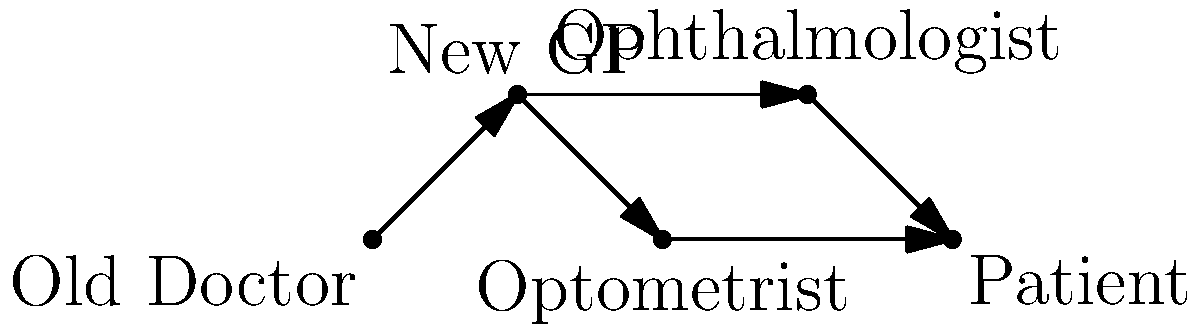In the given network graph representing the referral process for an annual sight check, what is the minimum number of steps (edges) required for the patient to reach the ophthalmologist from their old doctor? To determine the minimum number of steps required for the patient to reach the ophthalmologist from their old doctor, we need to analyze the graph:

1. Start at the "Old Doctor" node.
2. The only path from the "Old Doctor" is to the "New GP" (1 step).
3. From the "New GP", there are two possible paths:
   a. Directly to the "Ophthalmologist" (1 more step)
   b. To the "Optometrist" and then to the patient (not leading to the ophthalmologist)
4. The shortest path is: Old Doctor → New GP → Ophthalmologist

Therefore, the minimum number of steps (edges) required is 2.
Answer: 2 